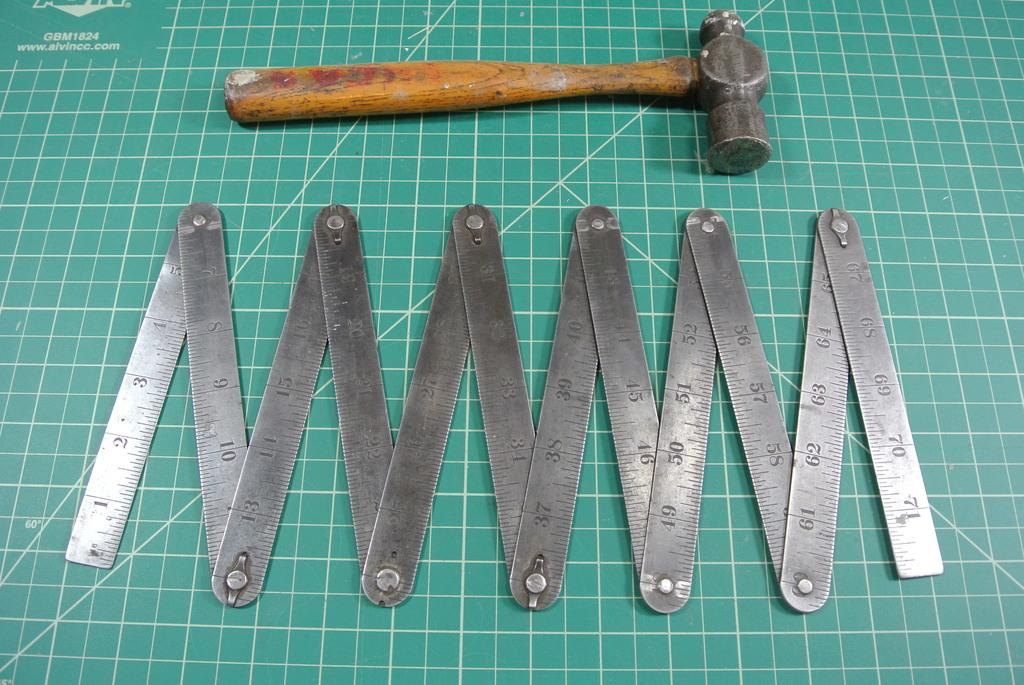How long is this ruler?
Offer a terse response. 71. 